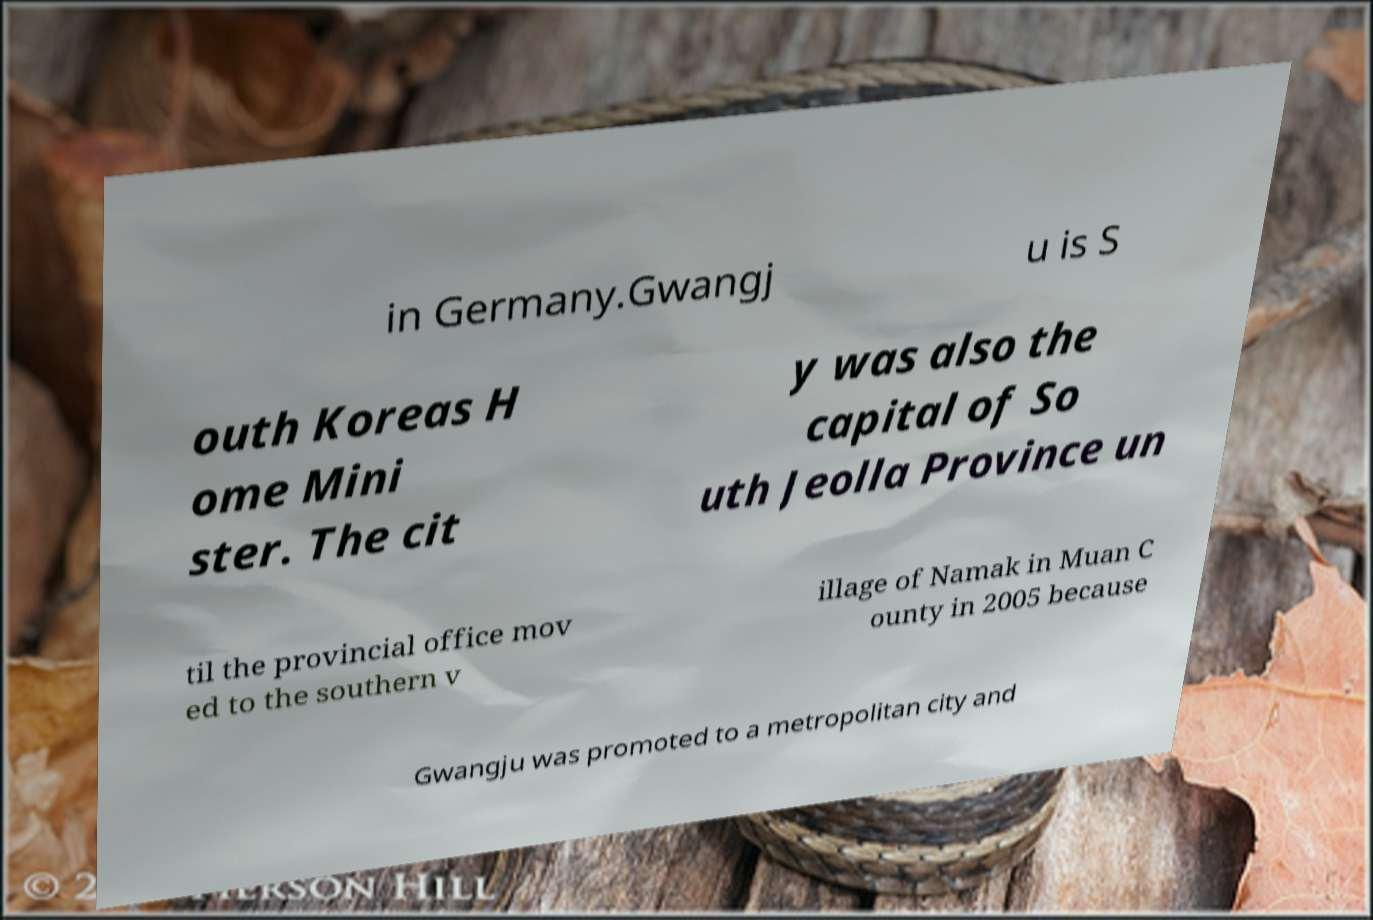Please identify and transcribe the text found in this image. in Germany.Gwangj u is S outh Koreas H ome Mini ster. The cit y was also the capital of So uth Jeolla Province un til the provincial office mov ed to the southern v illage of Namak in Muan C ounty in 2005 because Gwangju was promoted to a metropolitan city and 